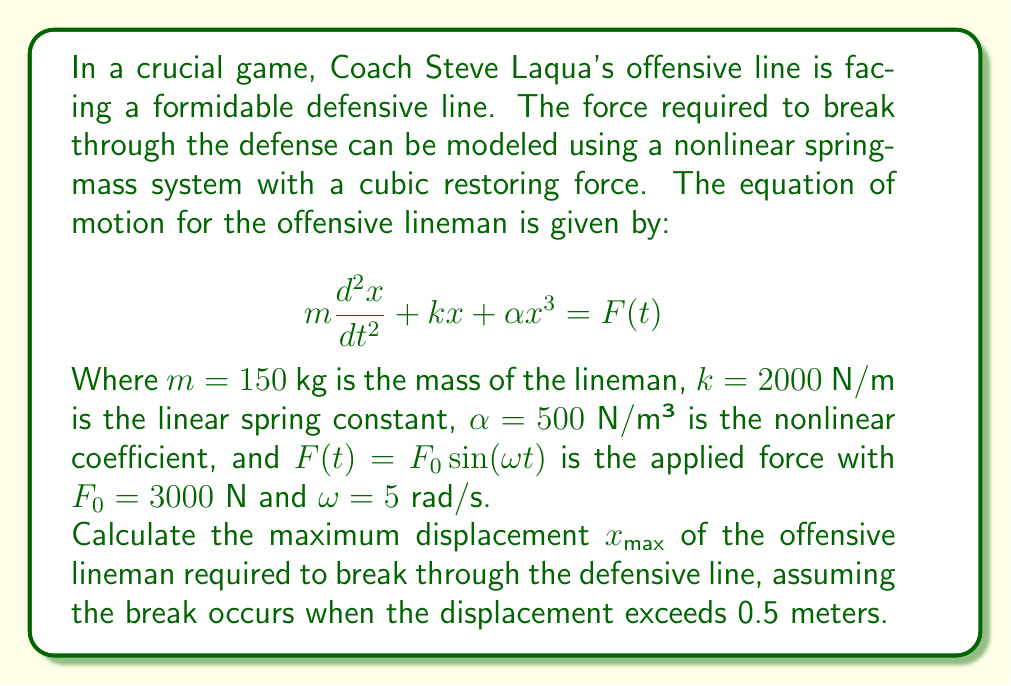Teach me how to tackle this problem. To solve this problem, we'll use the method of harmonic balance, which is suitable for nonlinear systems with periodic forcing.

Step 1: Assume a solution of the form $x(t) = A \sin(\omega t)$, where $A$ is the amplitude we want to find.

Step 2: Substitute this solution into the equation of motion:
$$-m\omega^2 A \sin(\omega t) + kA \sin(\omega t) + \alpha A^3 \sin^3(\omega t) = F_0 \sin(\omega t)$$

Step 3: Use the trigonometric identity $\sin^3(\omega t) = \frac{3}{4}\sin(\omega t) - \frac{1}{4}\sin(3\omega t)$ to simplify:
$$-m\omega^2 A \sin(\omega t) + kA \sin(\omega t) + \alpha A^3 (\frac{3}{4}\sin(\omega t) - \frac{1}{4}\sin(3\omega t)) = F_0 \sin(\omega t)$$

Step 4: Equate the coefficients of $\sin(\omega t)$ on both sides:
$$-m\omega^2 A + kA + \frac{3}{4}\alpha A^3 = F_0$$

Step 5: Substitute the given values:
$$-150 \cdot 5^2 \cdot A + 2000A + \frac{3}{4} \cdot 500 \cdot A^3 = 3000$$

Step 6: Simplify:
$$-3750A + 2000A + 375A^3 = 3000$$
$$375A^3 - 1750A - 3000 = 0$$

Step 7: This is a cubic equation. We can solve it numerically using Newton's method or a computer algebra system. The positive real root of this equation is approximately:

$$A \approx 0.5385$$

Step 8: Since the maximum displacement $x_{max}$ is equal to the amplitude $A$, we have found our solution.
Answer: $x_{max} \approx 0.5385$ meters 